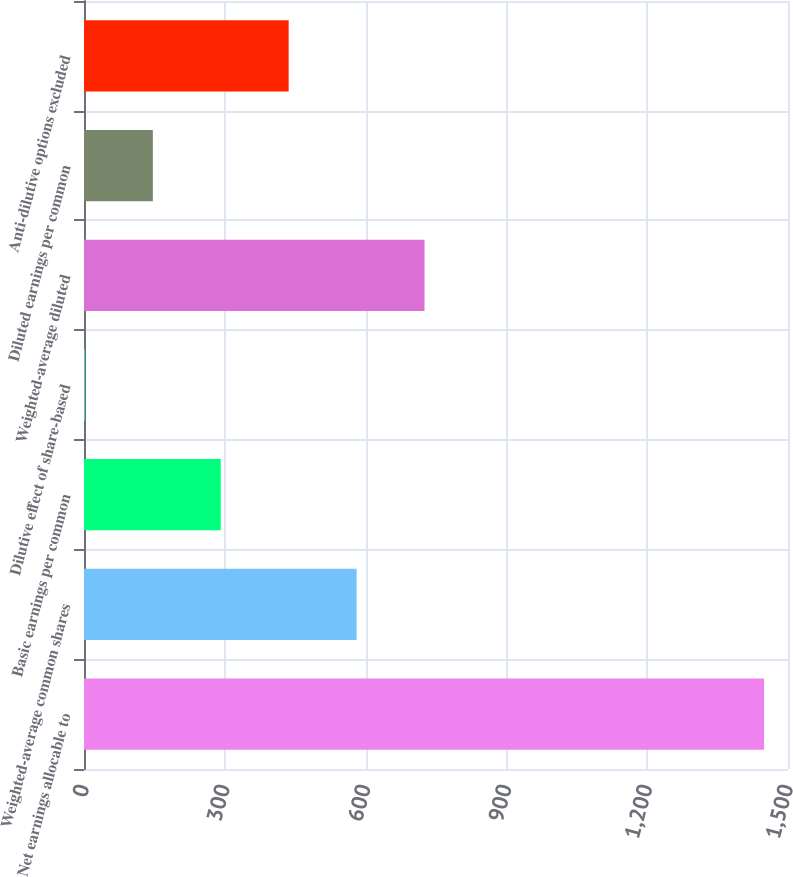<chart> <loc_0><loc_0><loc_500><loc_500><bar_chart><fcel>Net earnings allocable to<fcel>Weighted-average common shares<fcel>Basic earnings per common<fcel>Dilutive effect of share-based<fcel>Weighted-average diluted<fcel>Diluted earnings per common<fcel>Anti-dilutive options excluded<nl><fcel>1449<fcel>580.8<fcel>291.4<fcel>2<fcel>725.5<fcel>146.7<fcel>436.1<nl></chart> 